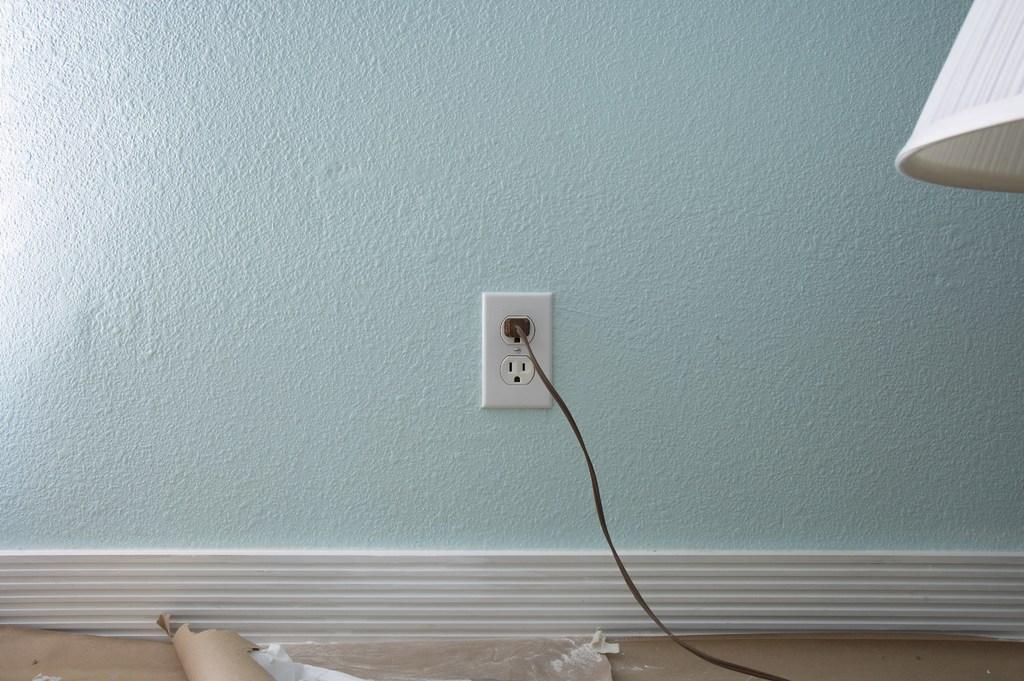Could you give a brief overview of what you see in this image? In this picture I can see the wall in front and in the center of this picture I can see a switch socket and I see a cable. On the right top of this image I can see a white color thing. On the bottom of this picture I see the brown color things. 